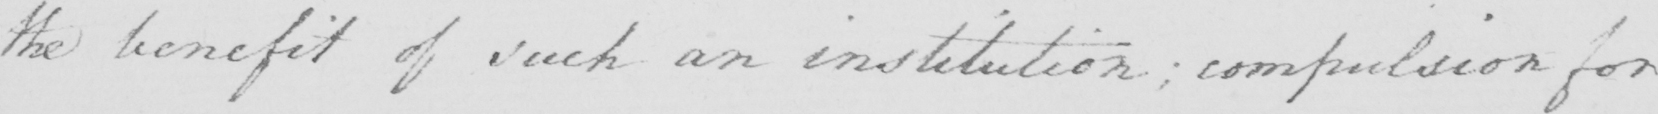What does this handwritten line say? the benefit of such an institution ; compulsion for 